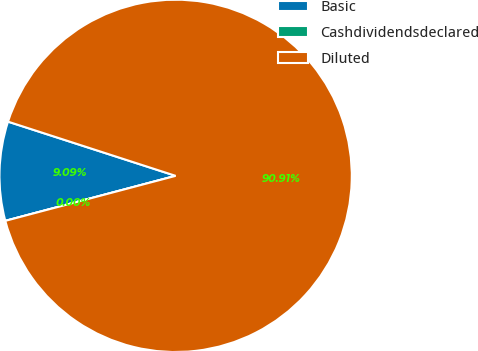<chart> <loc_0><loc_0><loc_500><loc_500><pie_chart><fcel>Basic<fcel>Cashdividendsdeclared<fcel>Diluted<nl><fcel>9.09%<fcel>0.0%<fcel>90.91%<nl></chart> 